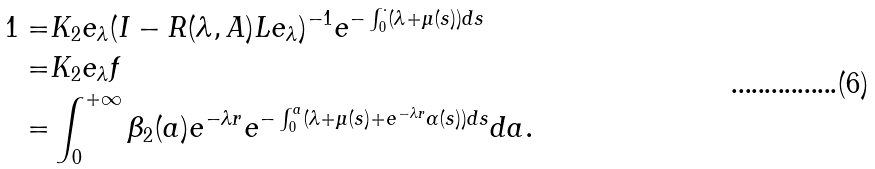<formula> <loc_0><loc_0><loc_500><loc_500>1 = & K _ { 2 } e _ { \lambda } ( I - R ( \lambda , A ) L e _ { \lambda } ) ^ { - 1 } e ^ { - \int _ { 0 } ^ { \cdot } ( \lambda + \mu ( s ) ) d s } \\ = & K _ { 2 } e _ { \lambda } f \\ = & \int _ { 0 } ^ { + \infty } \beta _ { 2 } ( a ) e ^ { - \lambda r } e ^ { - \int _ { 0 } ^ { a } ( \lambda + \mu ( s ) + e ^ { - \lambda r } \alpha ( s ) ) d s } d a .</formula> 